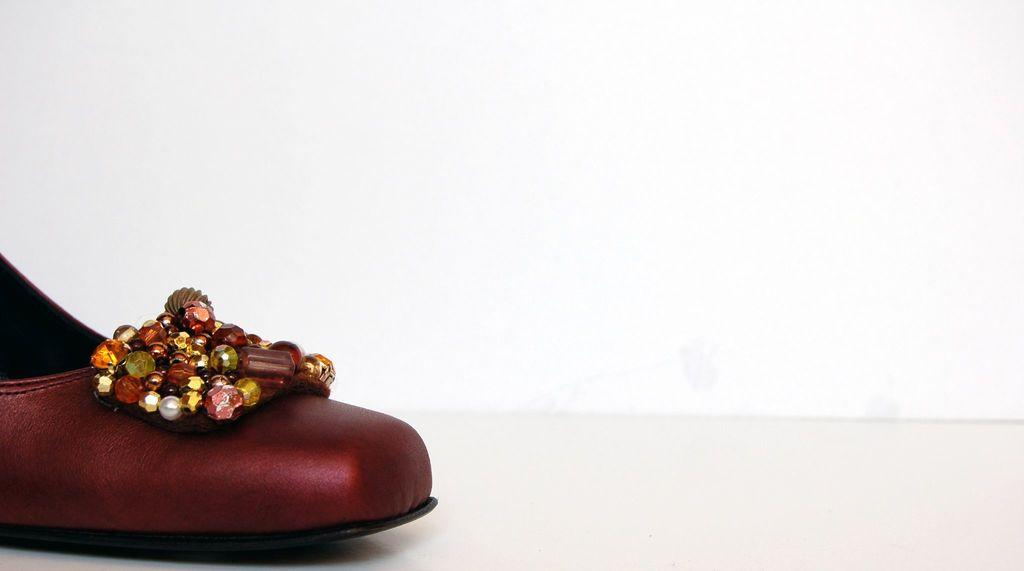What type of object is present on the white surface in the image? There is footwear in the image. Can you describe the surface on which the footwear is placed? The footwear is on a white surface. What is the color of the background in the image? The background of the image is white. What type of cake is visible in the image? There is no cake present in the image; it features footwear on a white surface with a white background. 